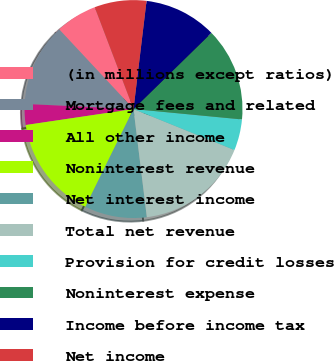Convert chart to OTSL. <chart><loc_0><loc_0><loc_500><loc_500><pie_chart><fcel>(in millions except ratios)<fcel>Mortgage fees and related<fcel>All other income<fcel>Noninterest revenue<fcel>Net interest income<fcel>Total net revenue<fcel>Provision for credit losses<fcel>Noninterest expense<fcel>Income before income tax<fcel>Net income<nl><fcel>6.16%<fcel>12.3%<fcel>3.09%<fcel>15.38%<fcel>9.23%<fcel>16.91%<fcel>4.62%<fcel>13.84%<fcel>10.77%<fcel>7.7%<nl></chart> 